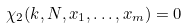<formula> <loc_0><loc_0><loc_500><loc_500>\chi _ { 2 } ( k , N , x _ { 1 } , \dots , x _ { m } ) = 0</formula> 